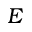Convert formula to latex. <formula><loc_0><loc_0><loc_500><loc_500>E</formula> 